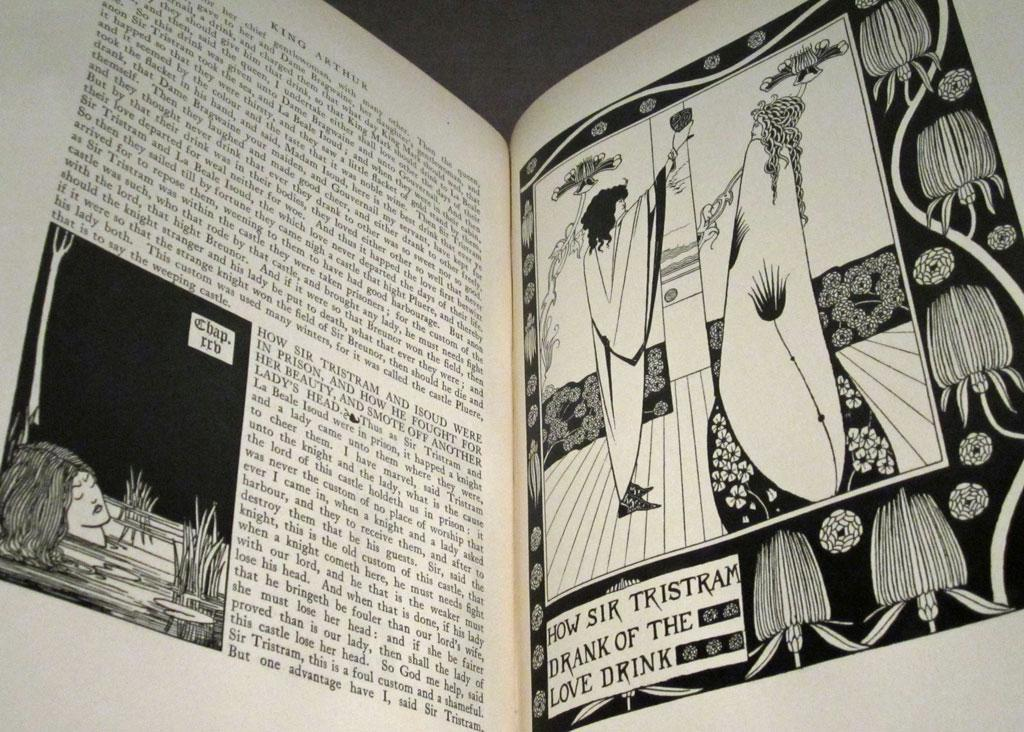<image>
Present a compact description of the photo's key features. the word Tristram is on the book with many pictures 